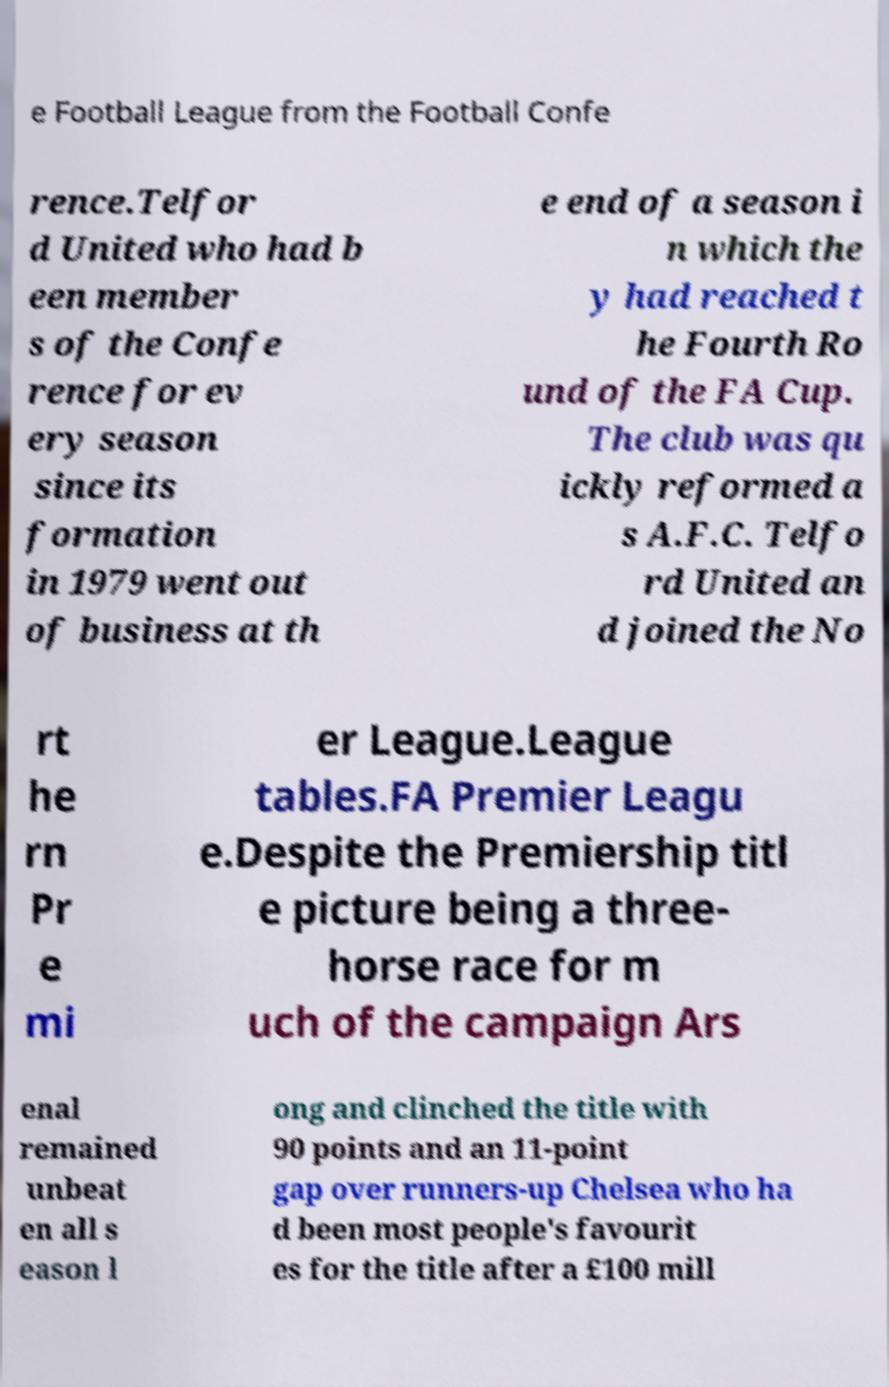Please identify and transcribe the text found in this image. e Football League from the Football Confe rence.Telfor d United who had b een member s of the Confe rence for ev ery season since its formation in 1979 went out of business at th e end of a season i n which the y had reached t he Fourth Ro und of the FA Cup. The club was qu ickly reformed a s A.F.C. Telfo rd United an d joined the No rt he rn Pr e mi er League.League tables.FA Premier Leagu e.Despite the Premiership titl e picture being a three- horse race for m uch of the campaign Ars enal remained unbeat en all s eason l ong and clinched the title with 90 points and an 11-point gap over runners-up Chelsea who ha d been most people's favourit es for the title after a £100 mill 